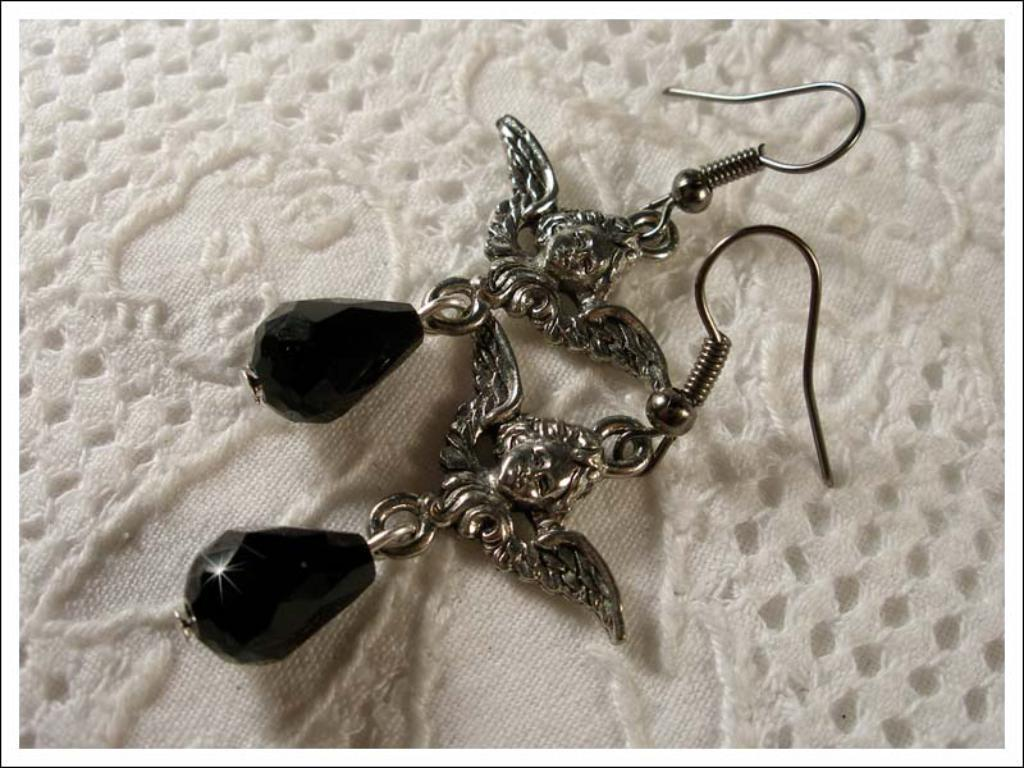What type of accessory is present in the image? There are earrings in the image. What is the earrings placed on? The earrings are on a white-colored cloth. What type of pet can be seen wearing the earrings in the image? There is no pet present in the image, and the earrings are not being worn by any living creature. 